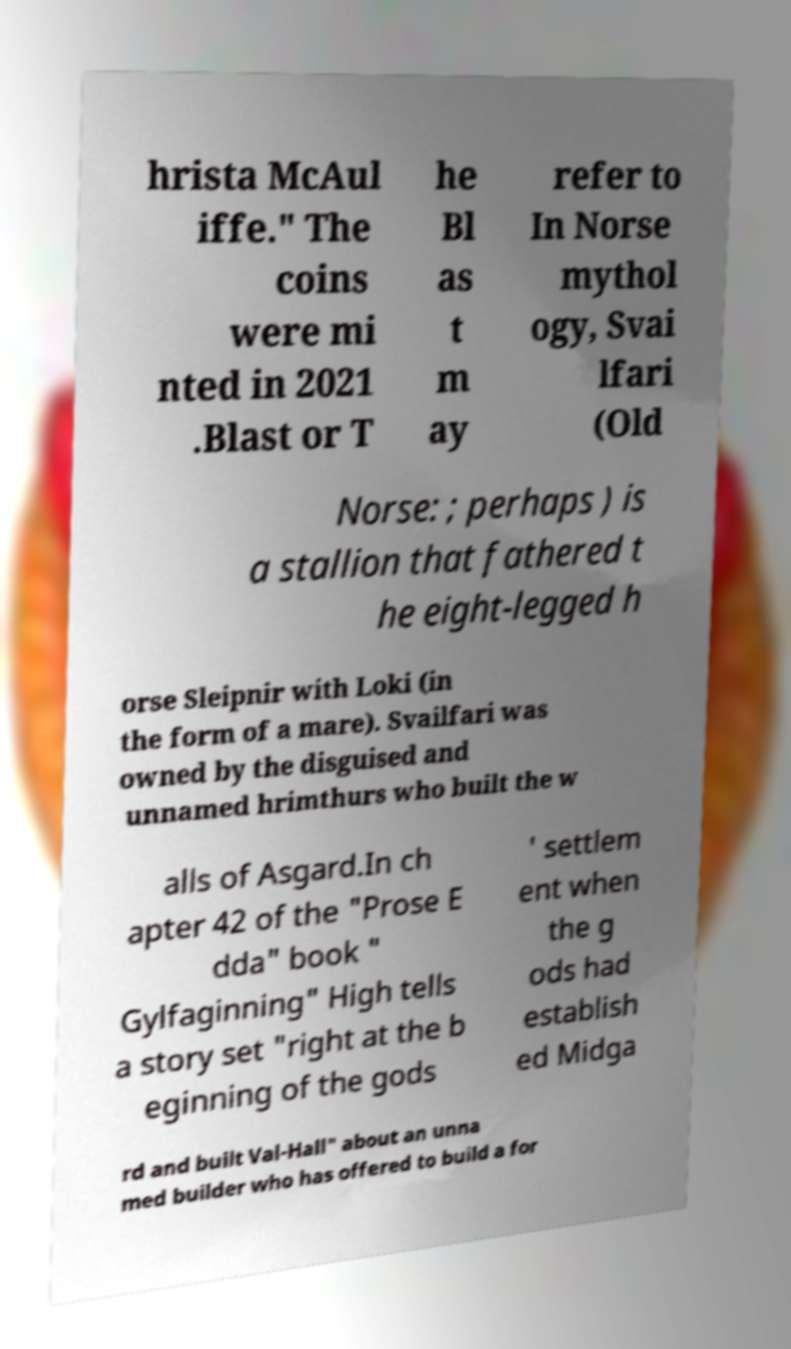What messages or text are displayed in this image? I need them in a readable, typed format. hrista McAul iffe." The coins were mi nted in 2021 .Blast or T he Bl as t m ay refer to In Norse mythol ogy, Svai lfari (Old Norse: ; perhaps ) is a stallion that fathered t he eight-legged h orse Sleipnir with Loki (in the form of a mare). Svailfari was owned by the disguised and unnamed hrimthurs who built the w alls of Asgard.In ch apter 42 of the "Prose E dda" book " Gylfaginning" High tells a story set "right at the b eginning of the gods ' settlem ent when the g ods had establish ed Midga rd and built Val-Hall" about an unna med builder who has offered to build a for 